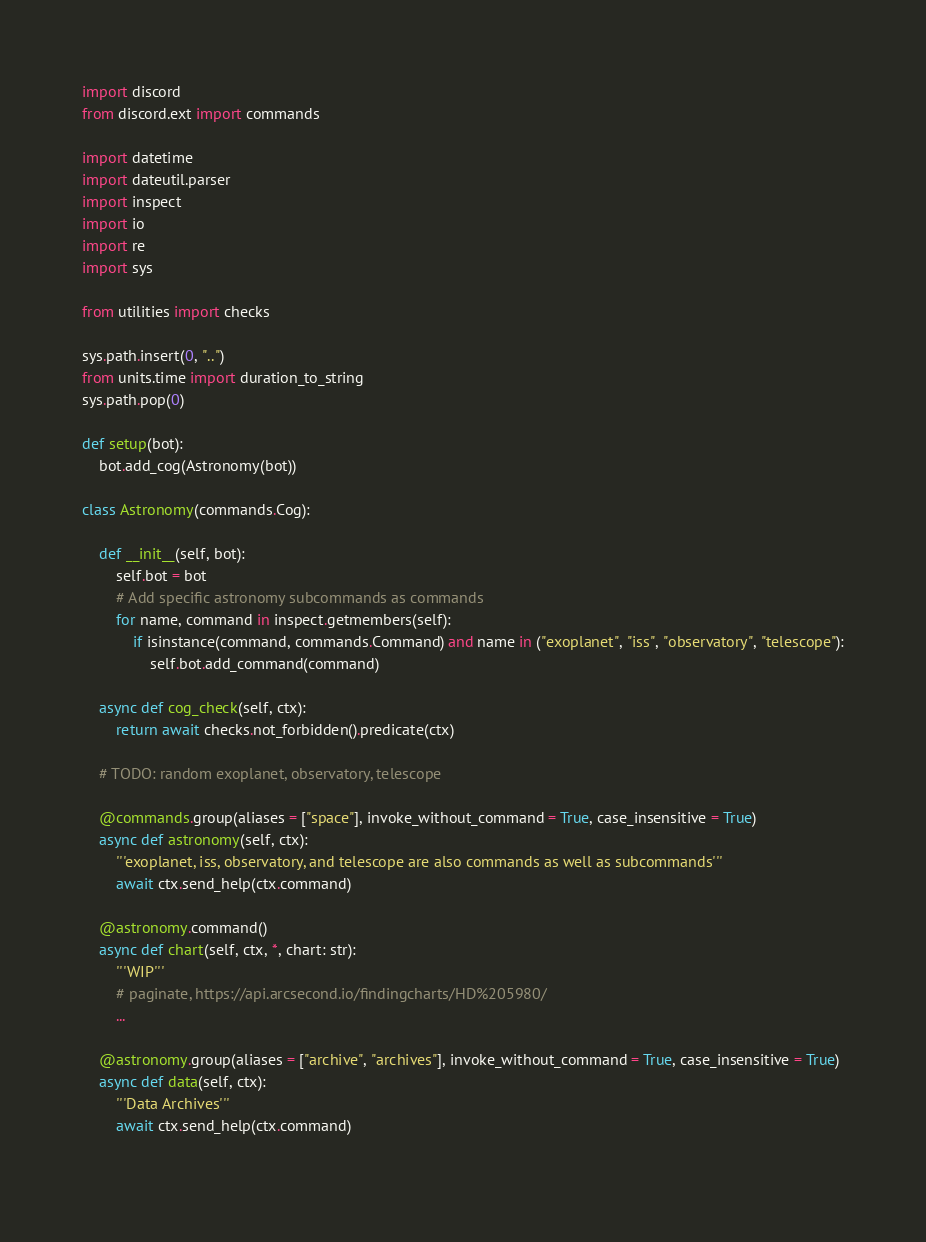Convert code to text. <code><loc_0><loc_0><loc_500><loc_500><_Python_>
import discord
from discord.ext import commands

import datetime
import dateutil.parser
import inspect
import io
import re
import sys

from utilities import checks

sys.path.insert(0, "..")
from units.time import duration_to_string
sys.path.pop(0)

def setup(bot):
	bot.add_cog(Astronomy(bot))

class Astronomy(commands.Cog):
	
	def __init__(self, bot):
		self.bot = bot
		# Add specific astronomy subcommands as commands
		for name, command in inspect.getmembers(self):
			if isinstance(command, commands.Command) and name in ("exoplanet", "iss", "observatory", "telescope"):
				self.bot.add_command(command)
	
	async def cog_check(self, ctx):
		return await checks.not_forbidden().predicate(ctx)
	
	# TODO: random exoplanet, observatory, telescope
	
	@commands.group(aliases = ["space"], invoke_without_command = True, case_insensitive = True)
	async def astronomy(self, ctx):
		'''exoplanet, iss, observatory, and telescope are also commands as well as subcommands'''
		await ctx.send_help(ctx.command)
	
	@astronomy.command()
	async def chart(self, ctx, *, chart: str):
		'''WIP'''
		# paginate, https://api.arcsecond.io/findingcharts/HD%205980/
		...
	
	@astronomy.group(aliases = ["archive", "archives"], invoke_without_command = True, case_insensitive = True)
	async def data(self, ctx):
		'''Data Archives'''
		await ctx.send_help(ctx.command)
	</code> 